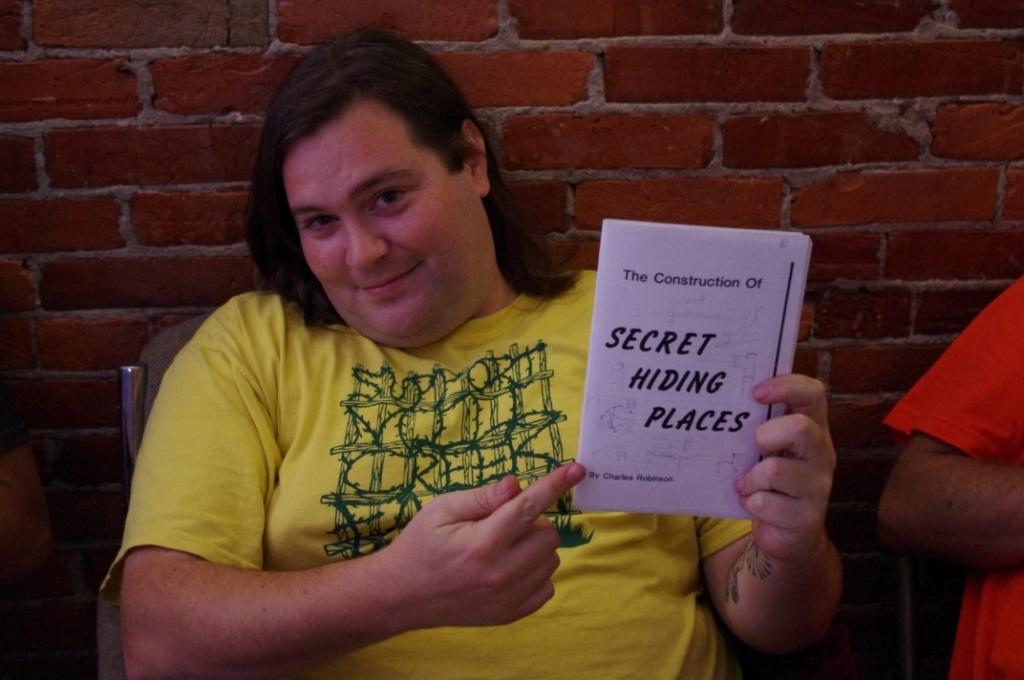What is this man proud of ?
Provide a short and direct response. Secret hiding places. What is this a guide for constructing?
Your response must be concise. Secret hiding places. 